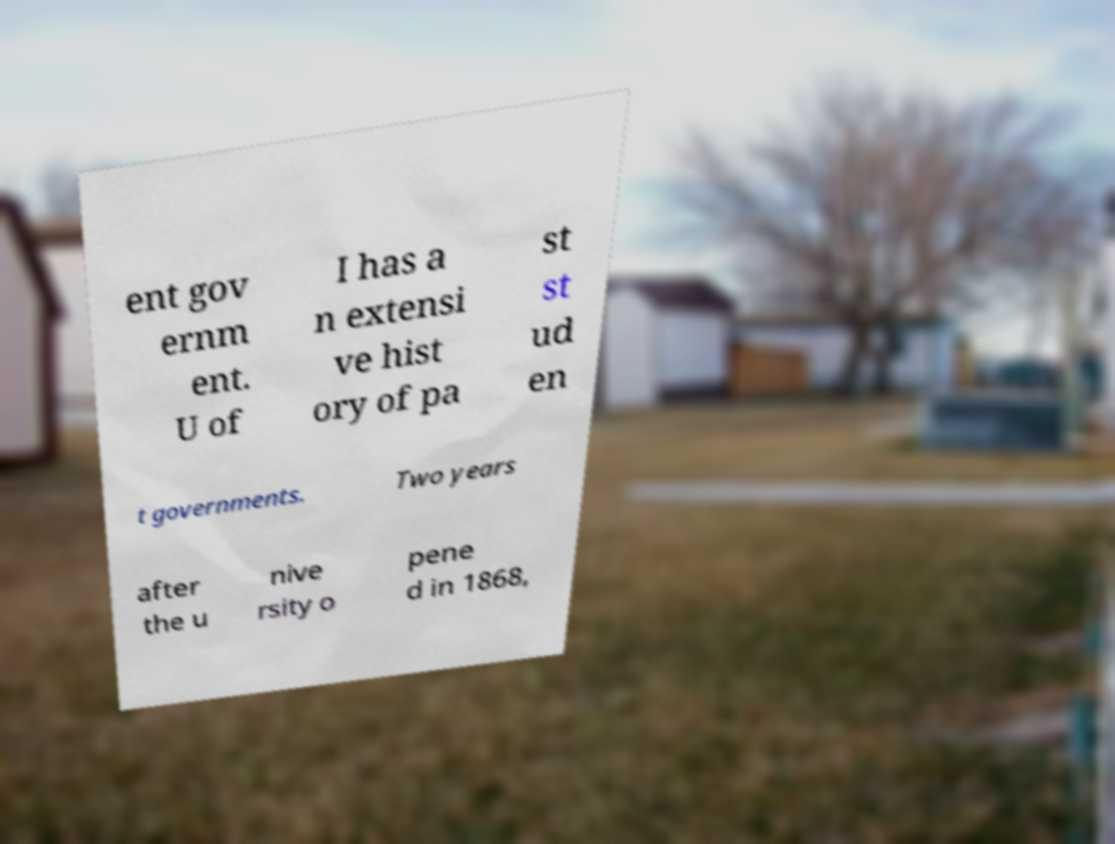Can you read and provide the text displayed in the image?This photo seems to have some interesting text. Can you extract and type it out for me? ent gov ernm ent. U of I has a n extensi ve hist ory of pa st st ud en t governments. Two years after the u nive rsity o pene d in 1868, 